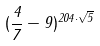<formula> <loc_0><loc_0><loc_500><loc_500>( \frac { 4 } { 7 } - 9 ) ^ { 2 0 4 \cdot \sqrt { 5 } }</formula> 